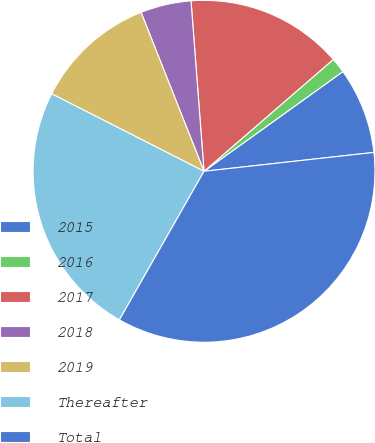Convert chart. <chart><loc_0><loc_0><loc_500><loc_500><pie_chart><fcel>2015<fcel>2016<fcel>2017<fcel>2018<fcel>2019<fcel>Thereafter<fcel>Total<nl><fcel>8.15%<fcel>1.44%<fcel>14.86%<fcel>4.79%<fcel>11.51%<fcel>24.25%<fcel>35.0%<nl></chart> 